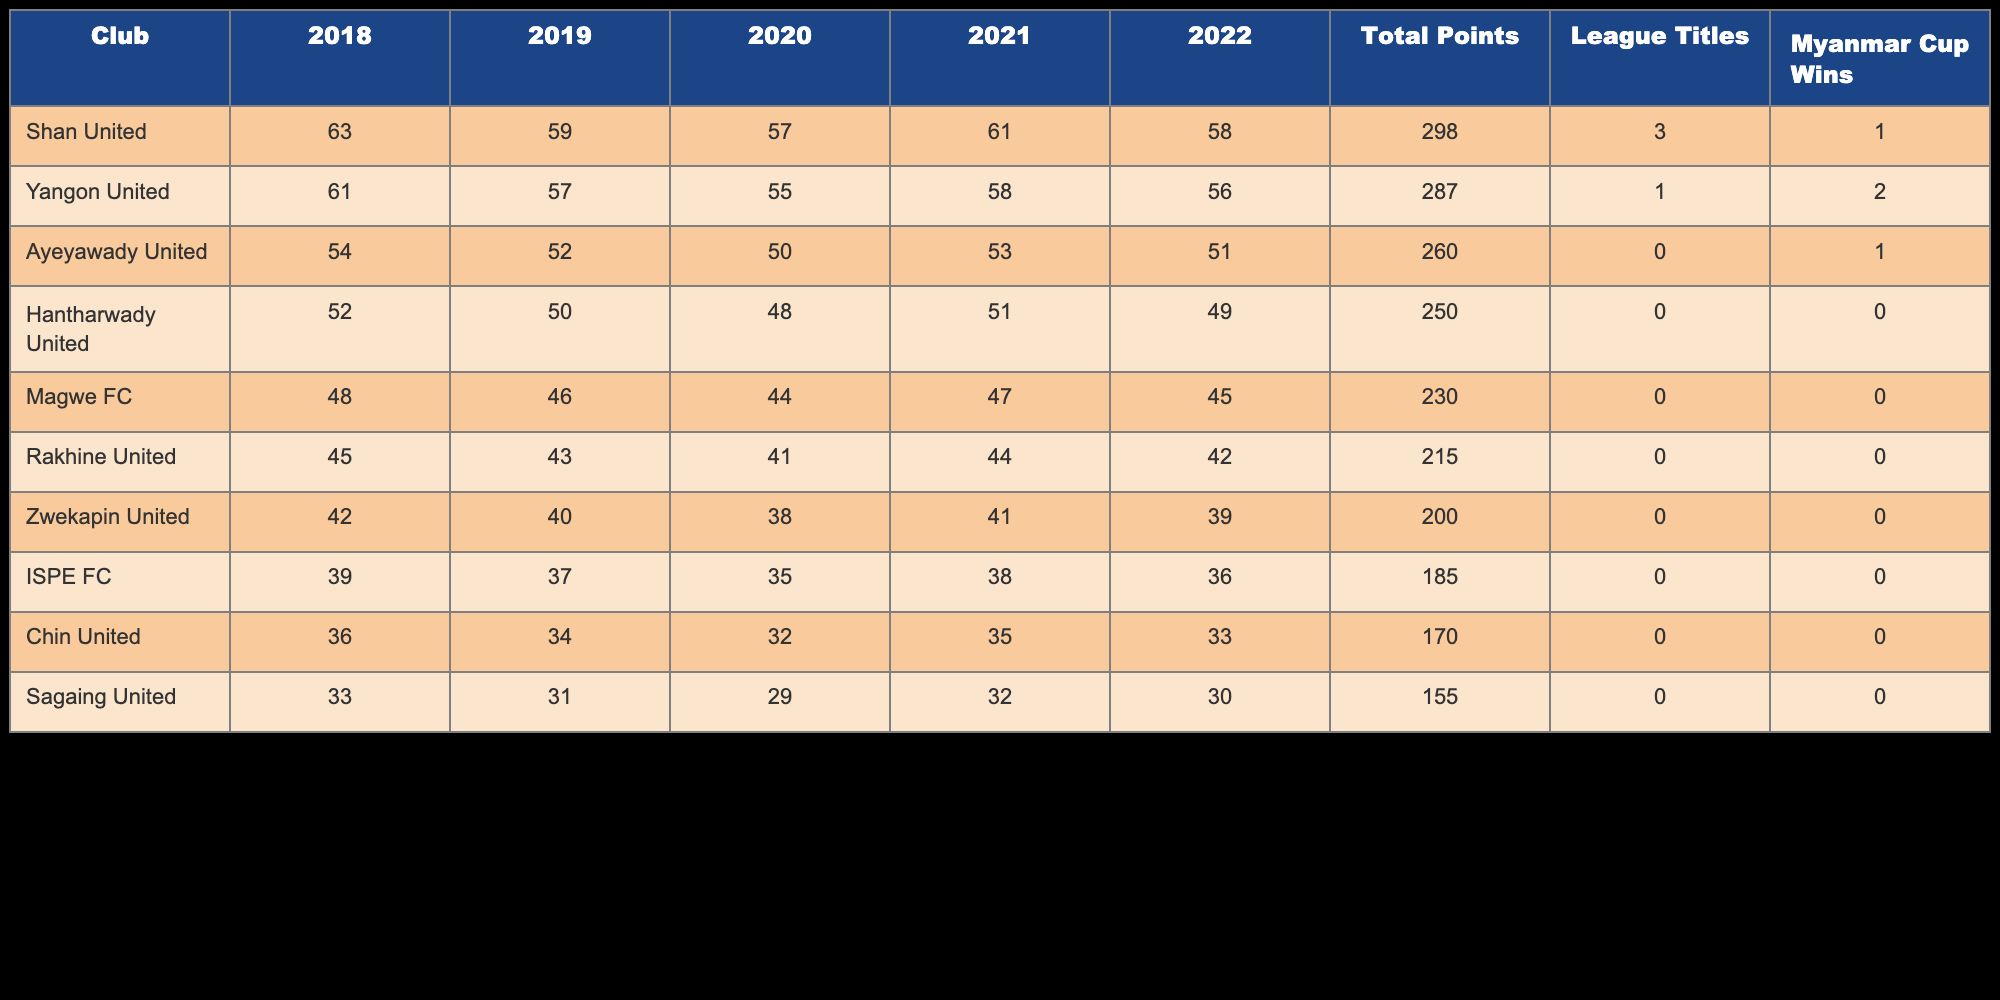What club has the highest total points over the past five seasons? Shan United has the highest total points with 298. This is gathered by inspecting the "Total Points" column of each club and identifying which value is the largest.
Answer: Shan United Did Yangon United win more league titles than Shan United? No, Yangon United has 1 league title while Shan United has 3 league titles, which is greater. We compare the values in the "League Titles" column for both clubs.
Answer: No What is the total number of league titles won by the clubs in the table? Adding up the league titles for all clubs gives us 3 (Shan United) + 1 (Yangon United) = 4. We sum the values in the "League Titles" column to find the total.
Answer: 4 Which club has the lowest total points and how many points do they have? Zwekapin United has the lowest total points with 200. This is determined by looking at the "Total Points" column and identifying the minimum value.
Answer: Zwekapin United, 200 Is it true that Ayeyawady United has won more Myanmar Cups than Hantharwady United? Yes, Ayeyawady United won 1 Myanmar Cup, while Hantharwady United has not won any. We check the "Myanmar Cup Wins" column for both clubs to validate this fact.
Answer: Yes What is the average total points of all clubs in the table? The total points for all clubs is 298 + 287 + 260 + 250 + 230 + 215 + 200 + 185 + 170 + 155 = 1855. There are 10 clubs, so the average total points is 1855 / 10 = 185.5. This is calculated by summing the total points and dividing by the number of clubs.
Answer: 185.5 Which club finished with the second-most total points? Yangon United finished with the second-most total points with 287. We identify the clubs sorted by "Total Points" and find that Yangon is second after Shan United.
Answer: Yangon United How many more Myanmar Cups did Shan United win compared to Magwe FC? Shan United won 1 Myanmar Cup and Magwe FC did not win any, so Shan United has 1 more than Magwe FC. We compare the "Myanmar Cup Wins" column for both clubs.
Answer: 1 